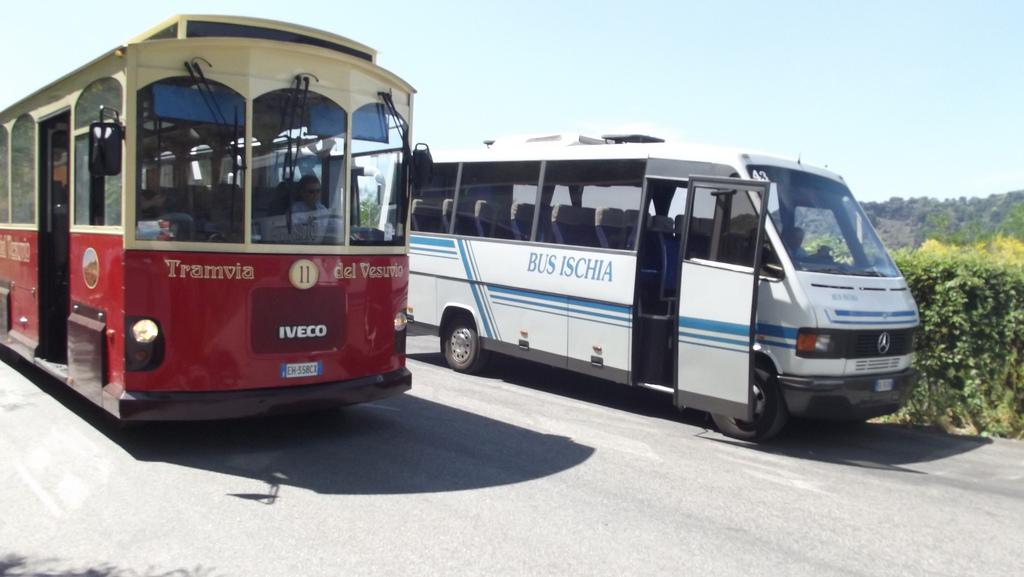Question: what should i wear?
Choices:
A. Something warm.
B. Something light.
C. They said to dress comfortable.
D. A brown hat.
Answer with the letter. Answer: C Question: how long does tour last?
Choices:
A. The rest of the day.
B. It last 4 hours.
C. Until the guide stops talking.
D. 3 hours.
Answer with the letter. Answer: B Question: what time do they plan to get back?
Choices:
A. They said by 1:30.
B. Just before the sun goes down.
C. Tomorrow morning.
D. Next tuesday.
Answer with the letter. Answer: A Question: what color are the license plates?
Choices:
A. Blue.
B. Gold.
C. Silver.
D. White.
Answer with the letter. Answer: D Question: what colors are on the trolley?
Choices:
A. Yellow and green.
B. Red and white.
C. Blue and gray.
D. Red and beige.
Answer with the letter. Answer: D Question: what does the newer style bus say?
Choices:
A. Bus ischia.
B. Manchester.
C. One man standing.
D. Blueberry.
Answer with the letter. Answer: A Question: what number is the red trolley?
Choices:
A. Eleven.
B. Three.
C. Eight.
D. Sixteen.
Answer with the letter. Answer: A Question: what make is the bus?
Choices:
A. Hummer.
B. Mercedes benz.
C. Range rover.
D. Vitz.
Answer with the letter. Answer: B Question: who gave the tour?
Choices:
A. An employee on the lot.
B. The owner of the vineyard.
C. The tour guide.
D. It is tour company in connection with hotel.
Answer with the letter. Answer: D 